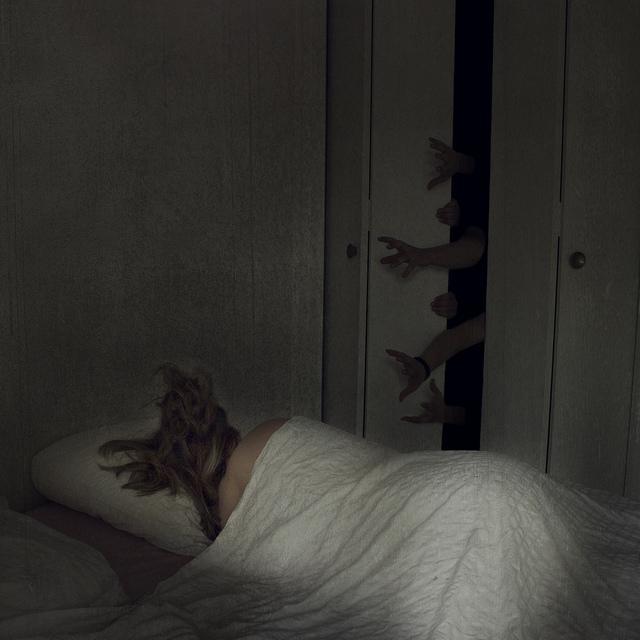What are coming out of the closet?
Pick the right solution, then justify: 'Answer: answer
Rationale: rationale.'
Options: Hands, heads, tentacles, feet. Answer: hands.
Rationale: Hands and bits of arms extend from out of the closets shadows in this bit of trick photography. 